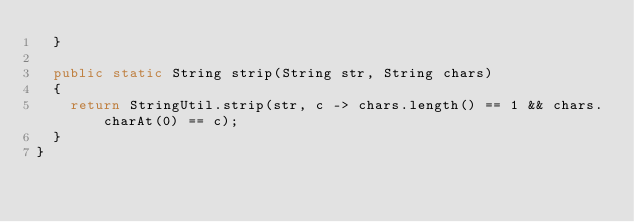Convert code to text. <code><loc_0><loc_0><loc_500><loc_500><_Java_>	}

	public static String strip(String str, String chars)
	{
		return StringUtil.strip(str, c -> chars.length() == 1 && chars.charAt(0) == c);
	}
}
</code> 